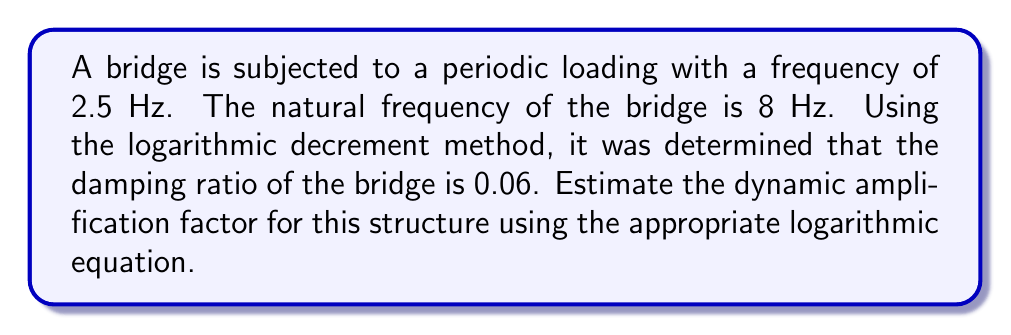Can you answer this question? To solve this problem, we'll follow these steps:

1) The dynamic amplification factor (DAF) for a structure subjected to harmonic loading is given by the equation:

   $$DAF = \frac{1}{\sqrt{(1-r^2)^2 + (2\zeta r)^2}}$$

   Where:
   $r$ is the frequency ratio
   $\zeta$ is the damping ratio

2) Calculate the frequency ratio $r$:
   $$r = \frac{\text{forcing frequency}}{\text{natural frequency}} = \frac{2.5 \text{ Hz}}{8 \text{ Hz}} = 0.3125$$

3) We're given the damping ratio $\zeta = 0.06$

4) Now, let's substitute these values into the DAF equation:

   $$DAF = \frac{1}{\sqrt{(1-(0.3125)^2)^2 + (2(0.06)(0.3125))^2}}$$

5) Simplify:
   $$DAF = \frac{1}{\sqrt{(1-0.0977)^2 + (0.0375)^2}}$$
   $$DAF = \frac{1}{\sqrt{(0.9023)^2 + (0.0375)^2}}$$
   $$DAF = \frac{1}{\sqrt{0.8141 + 0.0014}}$$
   $$DAF = \frac{1}{\sqrt{0.8155}}$$

6) Calculate the final result:
   $$DAF = \frac{1}{0.9031} = 1.1073$$

Therefore, the dynamic amplification factor for this structure is approximately 1.1073.
Answer: 1.1073 